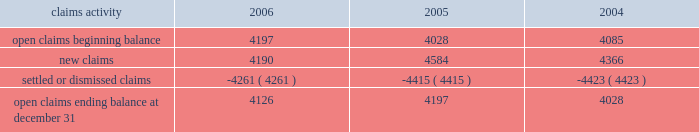Potentially responsible parties , and existing technology , laws , and regulations .
The ultimate liability for remediation is difficult to determine because of the number of potentially responsible parties involved , site- specific cost sharing arrangements with other potentially responsible parties , the degree of contamination by various wastes , the scarcity and quality of volumetric data related to many of the sites , and the speculative nature of remediation costs .
Current obligations are not expected to have a material adverse effect on our consolidated results of operations , financial condition , or liquidity .
Personal injury 2013 the cost of personal injuries to employees and others related to our activities is charged to expense based on estimates of the ultimate cost and number of incidents each year .
We use third-party actuaries to assist us with measuring the expense and liability , including unasserted claims .
The federal employers 2019 liability act ( fela ) governs compensation for work-related accidents .
Under fela , damages are assessed based on a finding of fault through litigation or out-of-court settlements .
We offer a comprehensive variety of services and rehabilitation programs for employees who are injured at work .
Annual expenses for personal injury-related events were $ 240 million in 2006 , $ 247 million in 2005 , and $ 288 million in 2004 .
As of december 31 , 2006 and 2005 , we had accrued liabilities of $ 631 million and $ 619 million for future personal injury costs , respectively , of which $ 233 million and $ 274 million was recorded in current liabilities as accrued casualty costs , respectively .
Our personal injury liability is discounted to present value using applicable u.s .
Treasury rates .
Approximately 87% ( 87 % ) of the recorded liability related to asserted claims , and approximately 13% ( 13 % ) related to unasserted claims .
Estimates can vary over time due to evolving trends in litigation .
Our personal injury claims activity was as follows : claims activity 2006 2005 2004 .
Depreciation 2013 the railroad industry is capital intensive .
Properties are carried at cost .
Provisions for depreciation are computed principally on the straight-line method based on estimated service lives of depreciable property .
The lives are calculated using a separate composite annual percentage rate for each depreciable property group , based on the results of internal depreciation studies .
We are required to submit a report on depreciation studies and proposed depreciation rates to the stb for review and approval every three years for equipment property and every six years for road property .
The cost ( net of salvage ) of depreciable railroad property retired or replaced in the ordinary course of business is charged to accumulated depreciation , and no gain or loss is recognized .
A gain or loss is recognized in other income for all other property upon disposition because the gain or loss is not part of rail operations .
The cost of internally developed software is capitalized and amortized over a five-year period .
Significant capital spending in recent years increased the total value of our depreciable assets .
Cash capital spending totaled $ 2.2 billion for the year ended december 31 , 2006 .
For the year ended december 31 , 2006 , depreciation expense was $ 1.2 billion .
We use various methods to estimate useful lives for each group of depreciable property .
Due to the capital intensive nature of the business and the large base of depreciable assets , variances to those estimates could have a material effect on our consolidated financial statements .
If the estimated useful lives of all depreciable assets were increased by one year , annual depreciation expense would decrease by approximately $ 43 million .
If the estimated useful lives of all assets to be depreciated were decreased by one year , annual depreciation expense would increase by approximately $ 45 million .
Income taxes 2013 as required under fasb statement no .
109 , accounting for income taxes , we account for income taxes by recording taxes payable or refundable for the current year and deferred tax assets and liabilities for the future tax consequences of events that have been recognized in our financial statements or tax returns .
These .
What was the percentage change in open claims ending balance at december 31 from 2005 to 2006? 
Computations: ((4126 - 4197) / 4197)
Answer: -0.01692. 